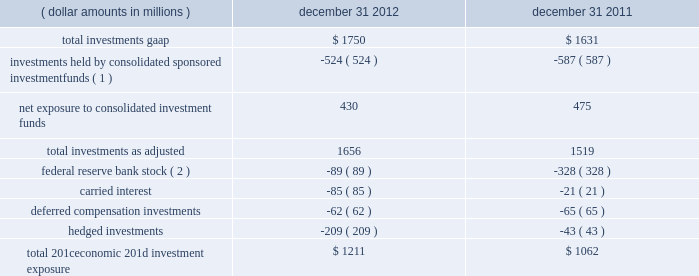The company further presents total net 201ceconomic 201d investment exposure , net of deferred compensation investments and hedged investments , to reflect another gauge for investors as the economic impact of investments held pursuant to deferred compensation arrangements is substantially offset by a change in compensation expense and the impact of hedged investments is substantially mitigated by total return swap hedges .
Carried interest capital allocations are excluded as there is no impact to blackrock 2019s stockholders 2019 equity until such amounts are realized as performance fees .
Finally , the company 2019s regulatory investment in federal reserve bank stock , which is not subject to market or interest rate risk , is excluded from the company 2019s net economic investment exposure .
( dollar amounts in millions ) december 31 , december 31 .
Total 201ceconomic 201d investment exposure .
$ 1211 $ 1062 ( 1 ) at december 31 , 2012 and december 31 , 2011 , approximately $ 524 million and $ 587 million , respectively , of blackrock 2019s total gaap investments were maintained in sponsored investment funds that were deemed to be controlled by blackrock in accordance with gaap , and , therefore , are consolidated even though blackrock may not economically own a majority of such funds .
( 2 ) the decrease of $ 239 million related to a lower holding requirement of federal reserve bank stock held by blackrock institutional trust company , n.a .
( 201cbtc 201d ) .
Total investments , as adjusted , at december 31 , 2012 increased $ 137 million from december 31 , 2011 , resulting from $ 765 million of purchases/capital contributions , $ 185 million from positive market valuations and earnings from equity method investments , and $ 64 million from net additional carried interest capital allocations , partially offset by $ 742 million of sales/maturities and $ 135 million of distributions representing return of capital and return on investments. .
What is the percentage change in the balance of total investments gaap from 2011 to 2012? 
Computations: ((1750 - 1631) / 1631)
Answer: 0.07296. 